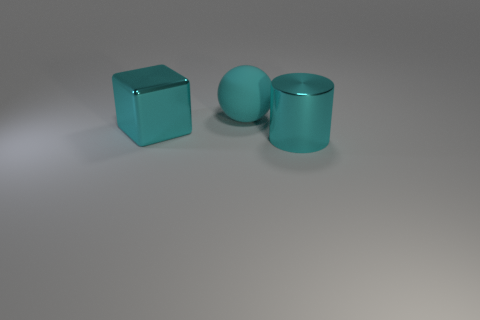How does the lighting in the image affect the appearance of the objects? The lighting in the image casts smooth, soft shadows, and highlights on the objects, emphasizing their geometric forms without creating harsh contrasts. It appears to be diffused overhead lighting that enhances the reflective quality of their surfaces, which indicates that they could be somewhat glossy. 